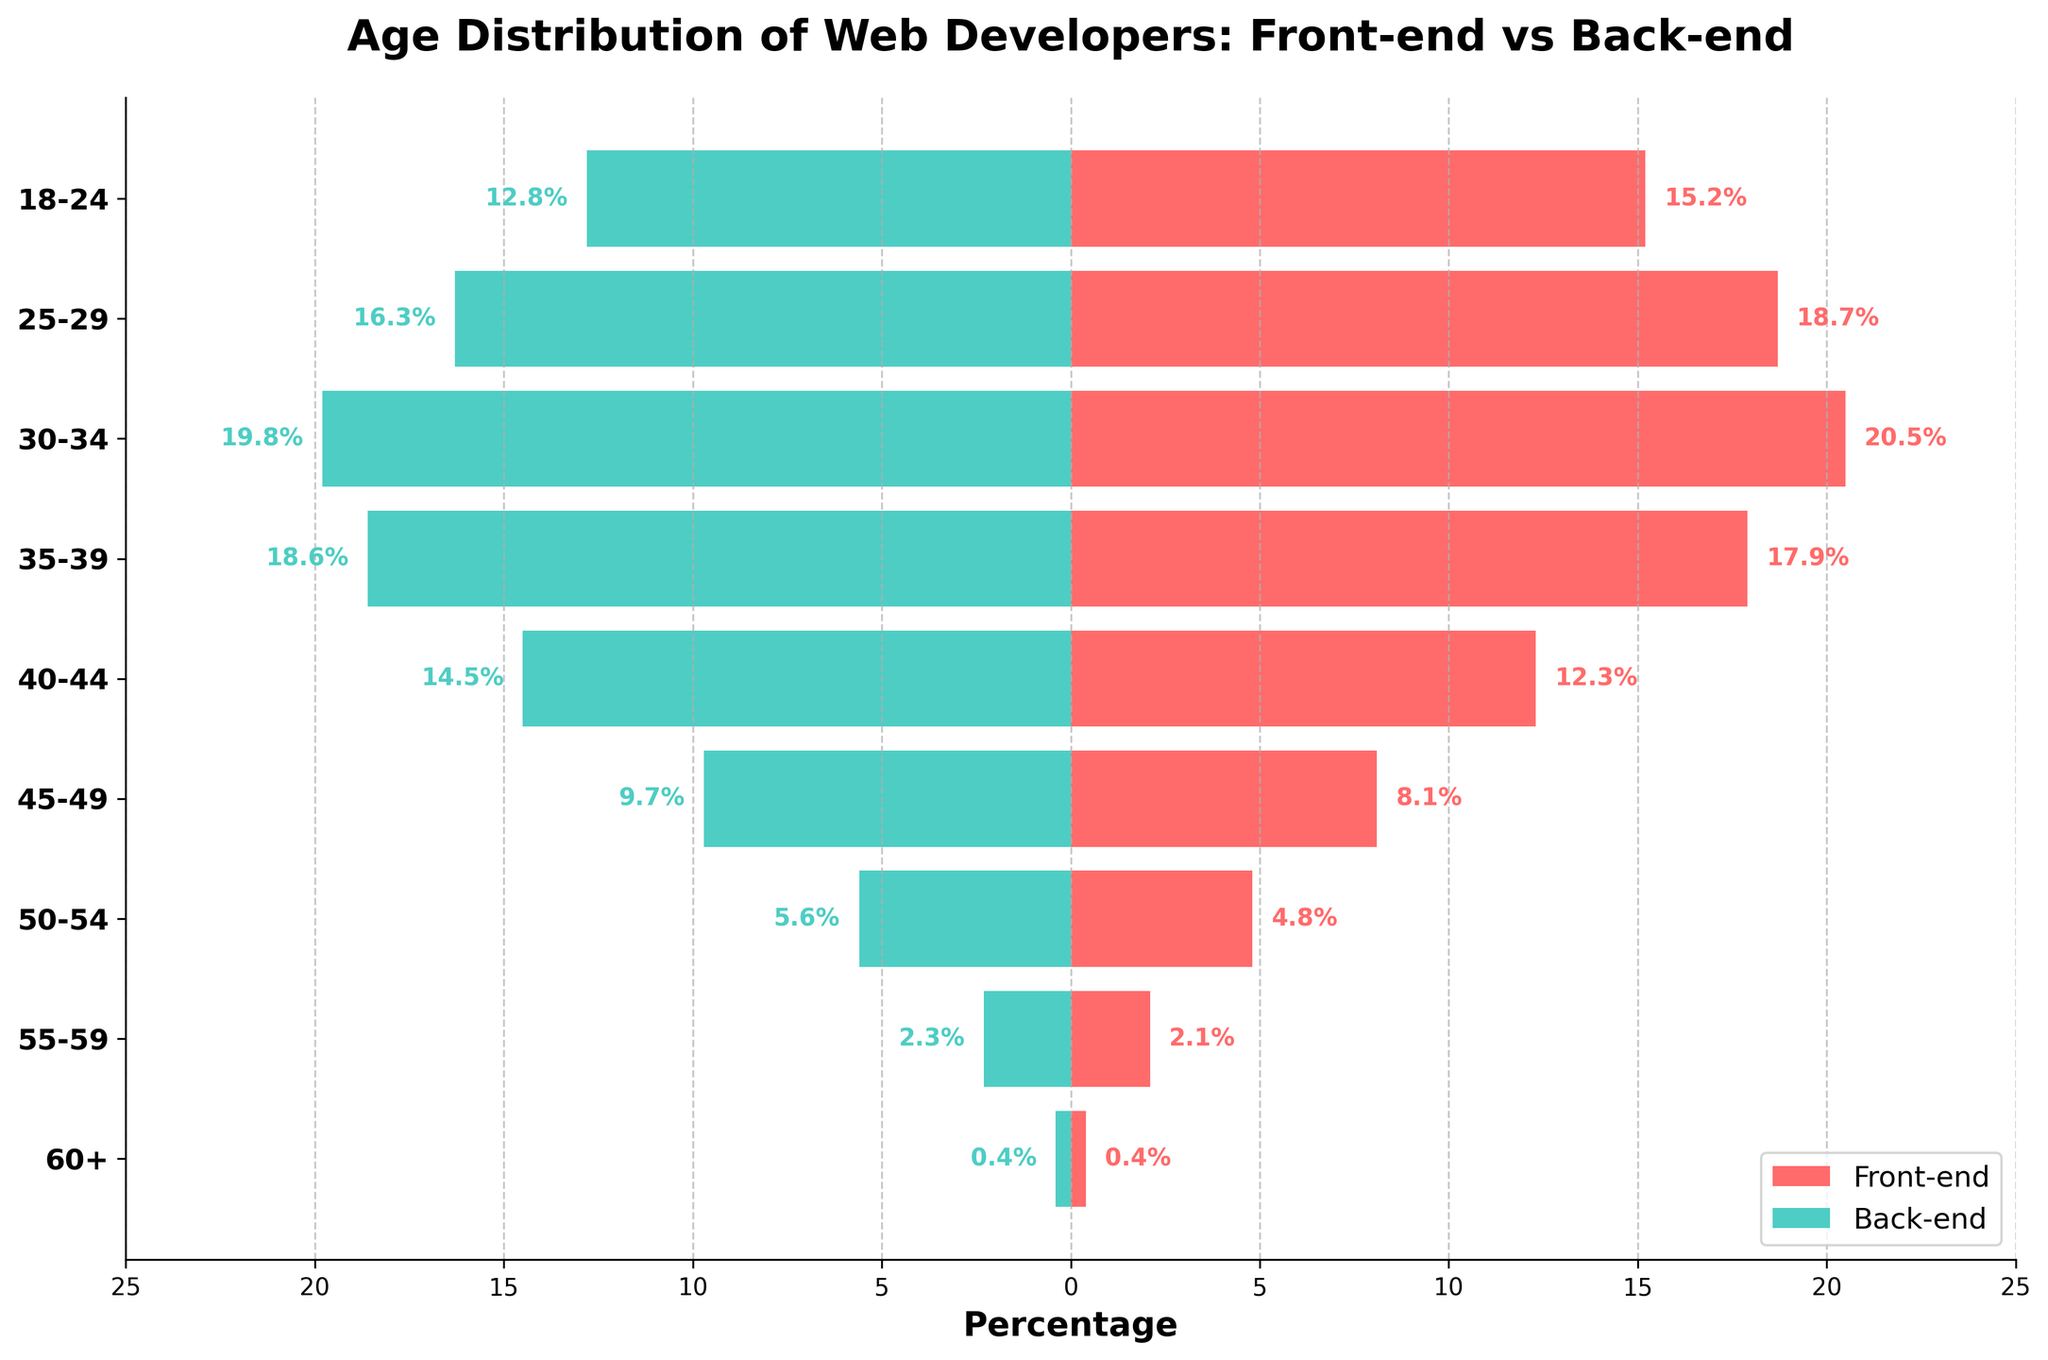What is the title of the figure? The title of the figure is located at the top and reads: "Age Distribution of Web Developers: Front-end vs Back-end".
Answer: Age Distribution of Web Developers: Front-end vs Back-end Which age group has the highest percentage of front-end developers? The figure shows different bars for each age group, with the percentage values labeled. The longest bar on the positive side (front-end) is for the age group 30-34, which is labeled 20.5%.
Answer: 30-34 Which age group has the highest percentage of back-end developers? Looking at the longer negative bars, the age group 30-34 also has the highest percentage of back-end developers, with a label of 19.8%.
Answer: 30-34 What is the percentage difference in the 25-29 age group for front-end and back-end developers? The front-end percentage is 18.7% and the back-end percentage is 16.3%. The difference is calculated as 18.7 - 16.3.
Answer: 2.4% Which color represents back-end developers in the figure? The back-end developers are represented by the bars colored in light green (specifically, the ones moving to the left side of the chart).
Answer: Light green In which age group is the percentage of front-end developers less than that of back-end developers? By comparing the lengths and direction of the bars for each age group, we see that for the 35-39 age group, the front-end percentage (17.9%) is less than the back-end percentage (18.6%).
Answer: 35-39 What is the total percentage of front-end developers for the age groups 18-24 and 25-29 combined? The percentages for the 18-24 and 25-29 age groups are 15.2% and 18.7%, respectively. Adding these gives 15.2 + 18.7.
Answer: 33.9% Which age group has the smallest percentage of front-end developers? The smallest value on the positive side (front-end) is 0.4%, corresponding to the age group 60+.
Answer: 60+ What is the total percentage of back-end developers for the age groups 45-49 and 50-54 combined? The percentages for the 45-49 and 50-54 age groups are 9.7% and 5.6%, respectively. Adding these values gives 9.7 + 5.6.
Answer: 15.3% What can you say about the distribution of developers aged 40-44 for front-end versus back-end? The figure shows that for the 40-44 age group, the percentage of front-end developers is 12.3%, while for back-end developers it is 14.5%. Therefore, there are more back-end developers in this age group.
Answer: More back-end developers 